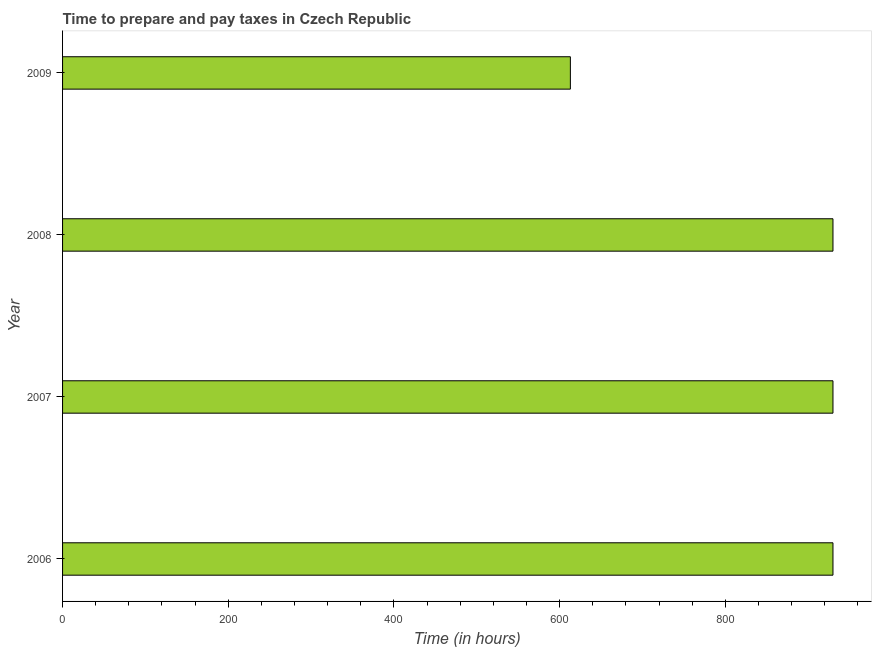Does the graph contain any zero values?
Make the answer very short. No. What is the title of the graph?
Ensure brevity in your answer.  Time to prepare and pay taxes in Czech Republic. What is the label or title of the X-axis?
Make the answer very short. Time (in hours). What is the label or title of the Y-axis?
Your answer should be compact. Year. What is the time to prepare and pay taxes in 2007?
Your answer should be compact. 930. Across all years, what is the maximum time to prepare and pay taxes?
Your answer should be very brief. 930. Across all years, what is the minimum time to prepare and pay taxes?
Your answer should be very brief. 613. In which year was the time to prepare and pay taxes maximum?
Ensure brevity in your answer.  2006. What is the sum of the time to prepare and pay taxes?
Make the answer very short. 3403. What is the difference between the time to prepare and pay taxes in 2006 and 2009?
Provide a succinct answer. 317. What is the average time to prepare and pay taxes per year?
Give a very brief answer. 850. What is the median time to prepare and pay taxes?
Provide a short and direct response. 930. In how many years, is the time to prepare and pay taxes greater than 200 hours?
Make the answer very short. 4. What is the ratio of the time to prepare and pay taxes in 2006 to that in 2007?
Give a very brief answer. 1. Is the sum of the time to prepare and pay taxes in 2008 and 2009 greater than the maximum time to prepare and pay taxes across all years?
Ensure brevity in your answer.  Yes. What is the difference between the highest and the lowest time to prepare and pay taxes?
Make the answer very short. 317. How many bars are there?
Your answer should be very brief. 4. Are all the bars in the graph horizontal?
Your response must be concise. Yes. What is the Time (in hours) of 2006?
Provide a short and direct response. 930. What is the Time (in hours) in 2007?
Offer a very short reply. 930. What is the Time (in hours) in 2008?
Offer a terse response. 930. What is the Time (in hours) in 2009?
Provide a short and direct response. 613. What is the difference between the Time (in hours) in 2006 and 2007?
Provide a succinct answer. 0. What is the difference between the Time (in hours) in 2006 and 2008?
Offer a very short reply. 0. What is the difference between the Time (in hours) in 2006 and 2009?
Make the answer very short. 317. What is the difference between the Time (in hours) in 2007 and 2009?
Provide a short and direct response. 317. What is the difference between the Time (in hours) in 2008 and 2009?
Your response must be concise. 317. What is the ratio of the Time (in hours) in 2006 to that in 2007?
Give a very brief answer. 1. What is the ratio of the Time (in hours) in 2006 to that in 2009?
Keep it short and to the point. 1.52. What is the ratio of the Time (in hours) in 2007 to that in 2009?
Offer a terse response. 1.52. What is the ratio of the Time (in hours) in 2008 to that in 2009?
Offer a very short reply. 1.52. 